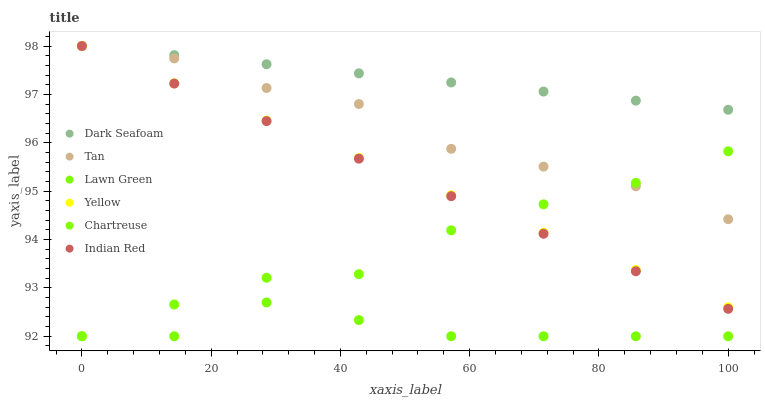Does Lawn Green have the minimum area under the curve?
Answer yes or no. Yes. Does Dark Seafoam have the maximum area under the curve?
Answer yes or no. Yes. Does Chartreuse have the minimum area under the curve?
Answer yes or no. No. Does Chartreuse have the maximum area under the curve?
Answer yes or no. No. Is Yellow the smoothest?
Answer yes or no. Yes. Is Lawn Green the roughest?
Answer yes or no. Yes. Is Chartreuse the smoothest?
Answer yes or no. No. Is Chartreuse the roughest?
Answer yes or no. No. Does Lawn Green have the lowest value?
Answer yes or no. Yes. Does Yellow have the lowest value?
Answer yes or no. No. Does Tan have the highest value?
Answer yes or no. Yes. Does Chartreuse have the highest value?
Answer yes or no. No. Is Chartreuse less than Dark Seafoam?
Answer yes or no. Yes. Is Dark Seafoam greater than Lawn Green?
Answer yes or no. Yes. Does Tan intersect Yellow?
Answer yes or no. Yes. Is Tan less than Yellow?
Answer yes or no. No. Is Tan greater than Yellow?
Answer yes or no. No. Does Chartreuse intersect Dark Seafoam?
Answer yes or no. No. 